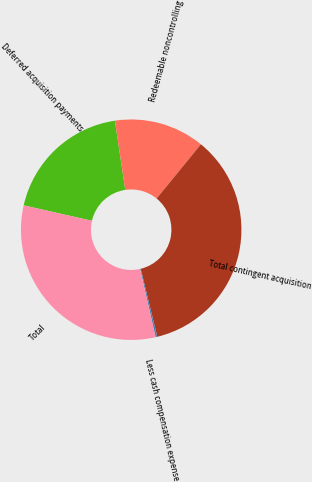Convert chart to OTSL. <chart><loc_0><loc_0><loc_500><loc_500><pie_chart><fcel>Deferred acquisition payments<fcel>Redeemable noncontrolling<fcel>Total contingent acquisition<fcel>Less cash compensation expense<fcel>Total<nl><fcel>19.1%<fcel>13.25%<fcel>35.3%<fcel>0.25%<fcel>32.09%<nl></chart> 